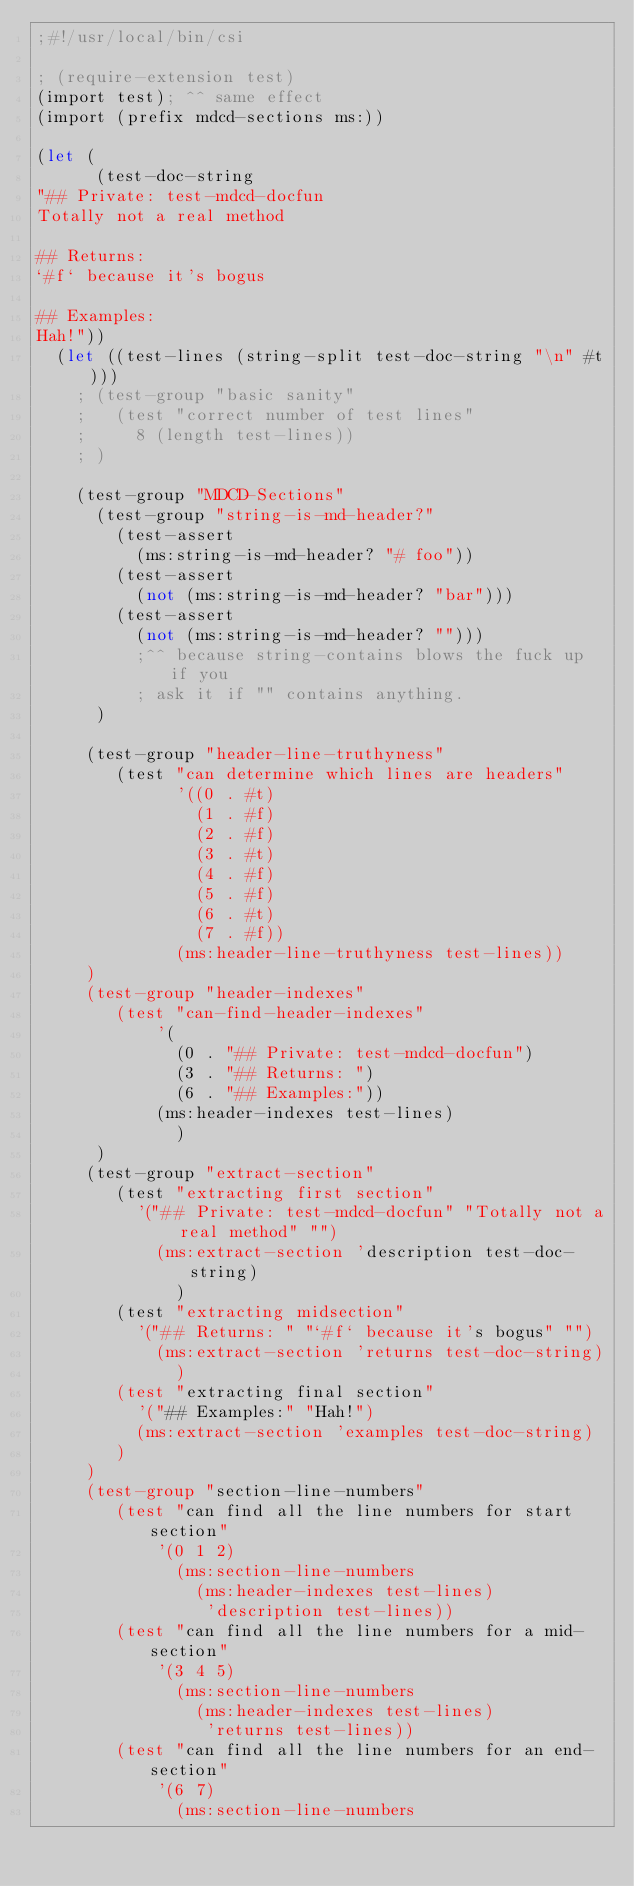Convert code to text. <code><loc_0><loc_0><loc_500><loc_500><_Scheme_>;#!/usr/local/bin/csi

; (require-extension test)
(import test); ^^ same effect
(import (prefix mdcd-sections ms:))

(let (
      (test-doc-string 
"## Private: test-mdcd-docfun
Totally not a real method

## Returns: 
`#f` because it's bogus

## Examples:
Hah!"))
  (let ((test-lines (string-split test-doc-string "\n" #t)))
    ; (test-group "basic sanity"
    ;   (test "correct number of test lines"
    ;     8 (length test-lines))
    ; )

    (test-group "MDCD-Sections"
      (test-group "string-is-md-header?"
        (test-assert 
          (ms:string-is-md-header? "# foo"))
        (test-assert
          (not (ms:string-is-md-header? "bar")))
        (test-assert
          (not (ms:string-is-md-header? "")))
          ;^^ because string-contains blows the fuck up if you
          ; ask it if "" contains anything.
      )

     (test-group "header-line-truthyness"
        (test "can determine which lines are headers"
              '((0 . #t) 
                (1 . #f) 
                (2 . #f)
                (3 . #t)
                (4 . #f)
                (5 . #f)
                (6 . #t)
                (7 . #f))
              (ms:header-line-truthyness test-lines))
     )
     (test-group "header-indexes"
        (test "can-find-header-indexes"
            '(
              (0 . "## Private: test-mdcd-docfun")
              (3 . "## Returns: ")
              (6 . "## Examples:"))
            (ms:header-indexes test-lines)
              )
      )
     (test-group "extract-section"
        (test "extracting first section"
          '("## Private: test-mdcd-docfun" "Totally not a real method" "")
            (ms:extract-section 'description test-doc-string)
              )
        (test "extracting midsection"
          '("## Returns: " "`#f` because it's bogus" "")
            (ms:extract-section 'returns test-doc-string)
              )
        (test "extracting final section"
          '("## Examples:" "Hah!")
          (ms:extract-section 'examples test-doc-string)
        )
     )
     (test-group "section-line-numbers"
        (test "can find all the line numbers for start section"
            '(0 1 2)
              (ms:section-line-numbers 
                (ms:header-indexes test-lines) 
                 'description test-lines))
        (test "can find all the line numbers for a mid-section"
            '(3 4 5)
              (ms:section-line-numbers 
                (ms:header-indexes test-lines) 
                 'returns test-lines))
        (test "can find all the line numbers for an end-section"
            '(6 7)
              (ms:section-line-numbers </code> 